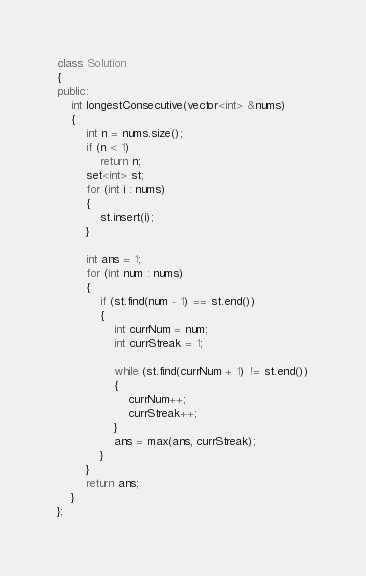<code> <loc_0><loc_0><loc_500><loc_500><_C++_>class Solution
{
public:
    int longestConsecutive(vector<int> &nums)
    {
        int n = nums.size();
        if (n < 1)
            return n;
        set<int> st;
        for (int i : nums)
        {
            st.insert(i);
        }

        int ans = 1;
        for (int num : nums)
        {
            if (st.find(num - 1) == st.end())
            {
                int currNum = num;
                int currStreak = 1;

                while (st.find(currNum + 1) != st.end())
                {
                    currNum++;
                    currStreak++;
                }
                ans = max(ans, currStreak);
            }
        }
        return ans;
    }
};
</code> 